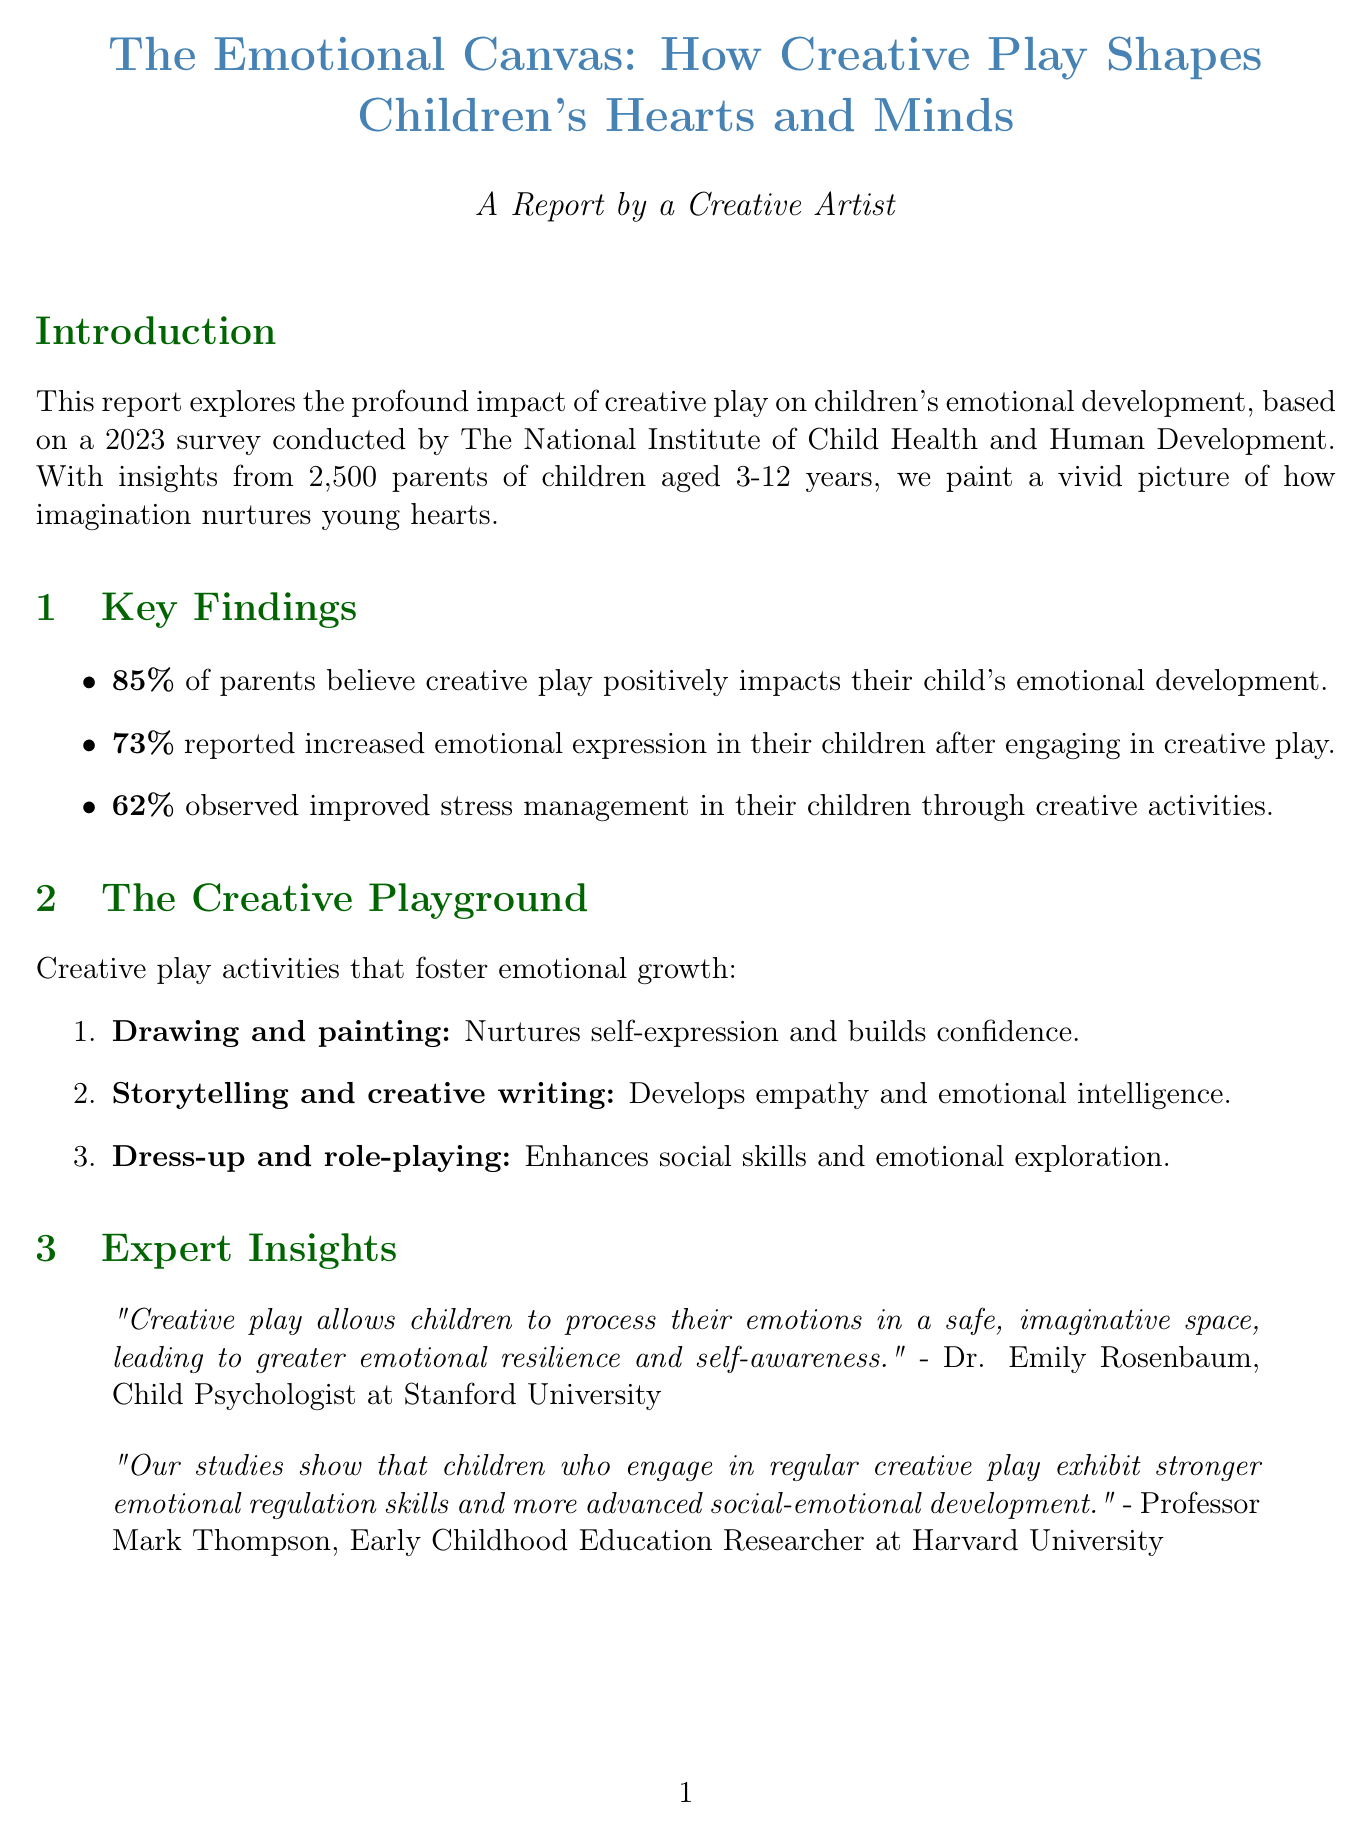what percentage of parents believe creative play positively impacts their child's emotional development? The statistic highlights the belief of parents regarding the positive effects of creative play on emotional development.
Answer: 85% how many parents reported increased emotional expression in their children? This statistic indicates the number of parents who noticed emotional expression improvements due to creative play.
Answer: 73% what is one activity listed that promotes empathy development? This activity exemplifies how storytelling can foster emotional intelligence in children.
Answer: Storytelling and creative writing who is the Child Psychologist quoted in the report? This question seeks to identify the expert providing insights on creative play's impact.
Answer: Dr. Emily Rosenbaum what long-term benefit is associated with creative play regarding communication? This benefit emphasizes how creative play can enhance crucial life skills such as expression and connection.
Answer: Improved communication abilities how many parents participated in the survey? This number signifies the scale of the survey conducted regarding creative play.
Answer: 2500 what is one recommendation for parents mentioned in the report? This question allows an exploration of actionable advice for parents to support their children's creative play.
Answer: Create a designated space for creative activities who documented a testimony about their child's emotional growth? This inquiry seeks to highlight a specific parent’s experience with creative play.
Answer: Michael Chen 